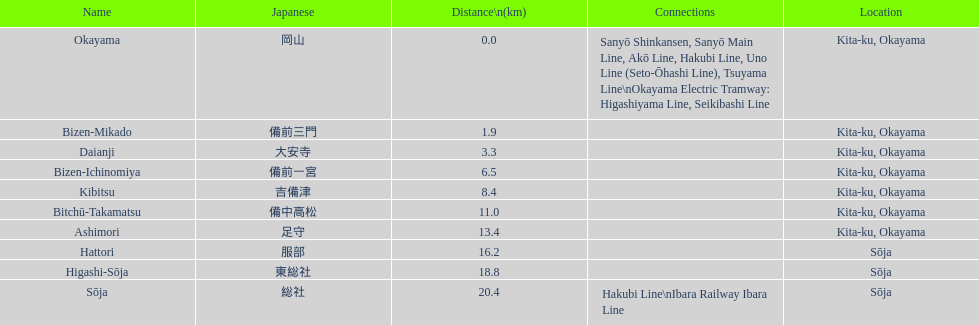Which has a distance shorter than Bizen-Mikado. 